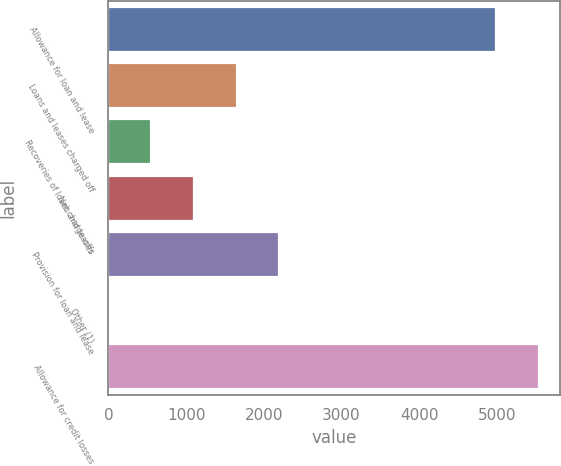Convert chart to OTSL. <chart><loc_0><loc_0><loc_500><loc_500><bar_chart><fcel>Allowance for loan and lease<fcel>Loans and leases charged off<fcel>Recoveries of loans and leases<fcel>Net charge-offs<fcel>Provision for loan and lease<fcel>Other (1)<fcel>Allowance for credit losses<nl><fcel>4986.4<fcel>1649.2<fcel>550.4<fcel>1099.8<fcel>2198.6<fcel>1<fcel>5535.8<nl></chart> 